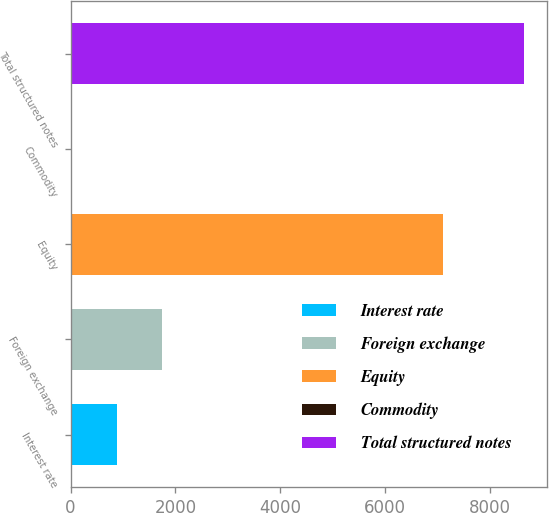<chart> <loc_0><loc_0><loc_500><loc_500><bar_chart><fcel>Interest rate<fcel>Foreign exchange<fcel>Equity<fcel>Commodity<fcel>Total structured notes<nl><fcel>878.4<fcel>1741.8<fcel>7106<fcel>15<fcel>8649<nl></chart> 